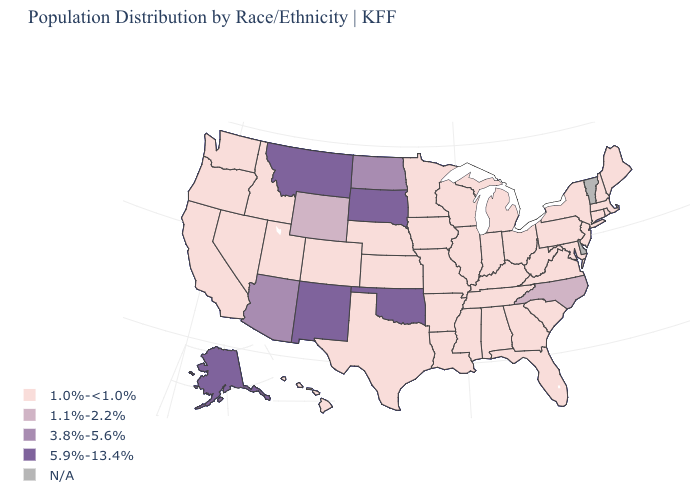Among the states that border Arkansas , does Mississippi have the lowest value?
Concise answer only. Yes. Name the states that have a value in the range 1.0%-<1.0%?
Give a very brief answer. Alabama, Arkansas, California, Colorado, Connecticut, Florida, Georgia, Hawaii, Idaho, Illinois, Indiana, Iowa, Kansas, Kentucky, Louisiana, Maine, Maryland, Massachusetts, Michigan, Minnesota, Mississippi, Missouri, Nebraska, Nevada, New Hampshire, New Jersey, New York, Ohio, Oregon, Pennsylvania, Rhode Island, South Carolina, Tennessee, Texas, Utah, Virginia, Washington, West Virginia, Wisconsin. Does the map have missing data?
Quick response, please. Yes. What is the value of Ohio?
Quick response, please. 1.0%-<1.0%. Name the states that have a value in the range 3.8%-5.6%?
Short answer required. Arizona, North Dakota. What is the highest value in the Northeast ?
Answer briefly. 1.0%-<1.0%. What is the value of Arizona?
Write a very short answer. 3.8%-5.6%. What is the value of South Carolina?
Be succinct. 1.0%-<1.0%. What is the value of South Dakota?
Short answer required. 5.9%-13.4%. Which states have the lowest value in the South?
Short answer required. Alabama, Arkansas, Florida, Georgia, Kentucky, Louisiana, Maryland, Mississippi, South Carolina, Tennessee, Texas, Virginia, West Virginia. What is the lowest value in the Northeast?
Keep it brief. 1.0%-<1.0%. Name the states that have a value in the range 1.1%-2.2%?
Write a very short answer. North Carolina, Wyoming. Name the states that have a value in the range N/A?
Answer briefly. Delaware, Vermont. Name the states that have a value in the range 5.9%-13.4%?
Answer briefly. Alaska, Montana, New Mexico, Oklahoma, South Dakota. 